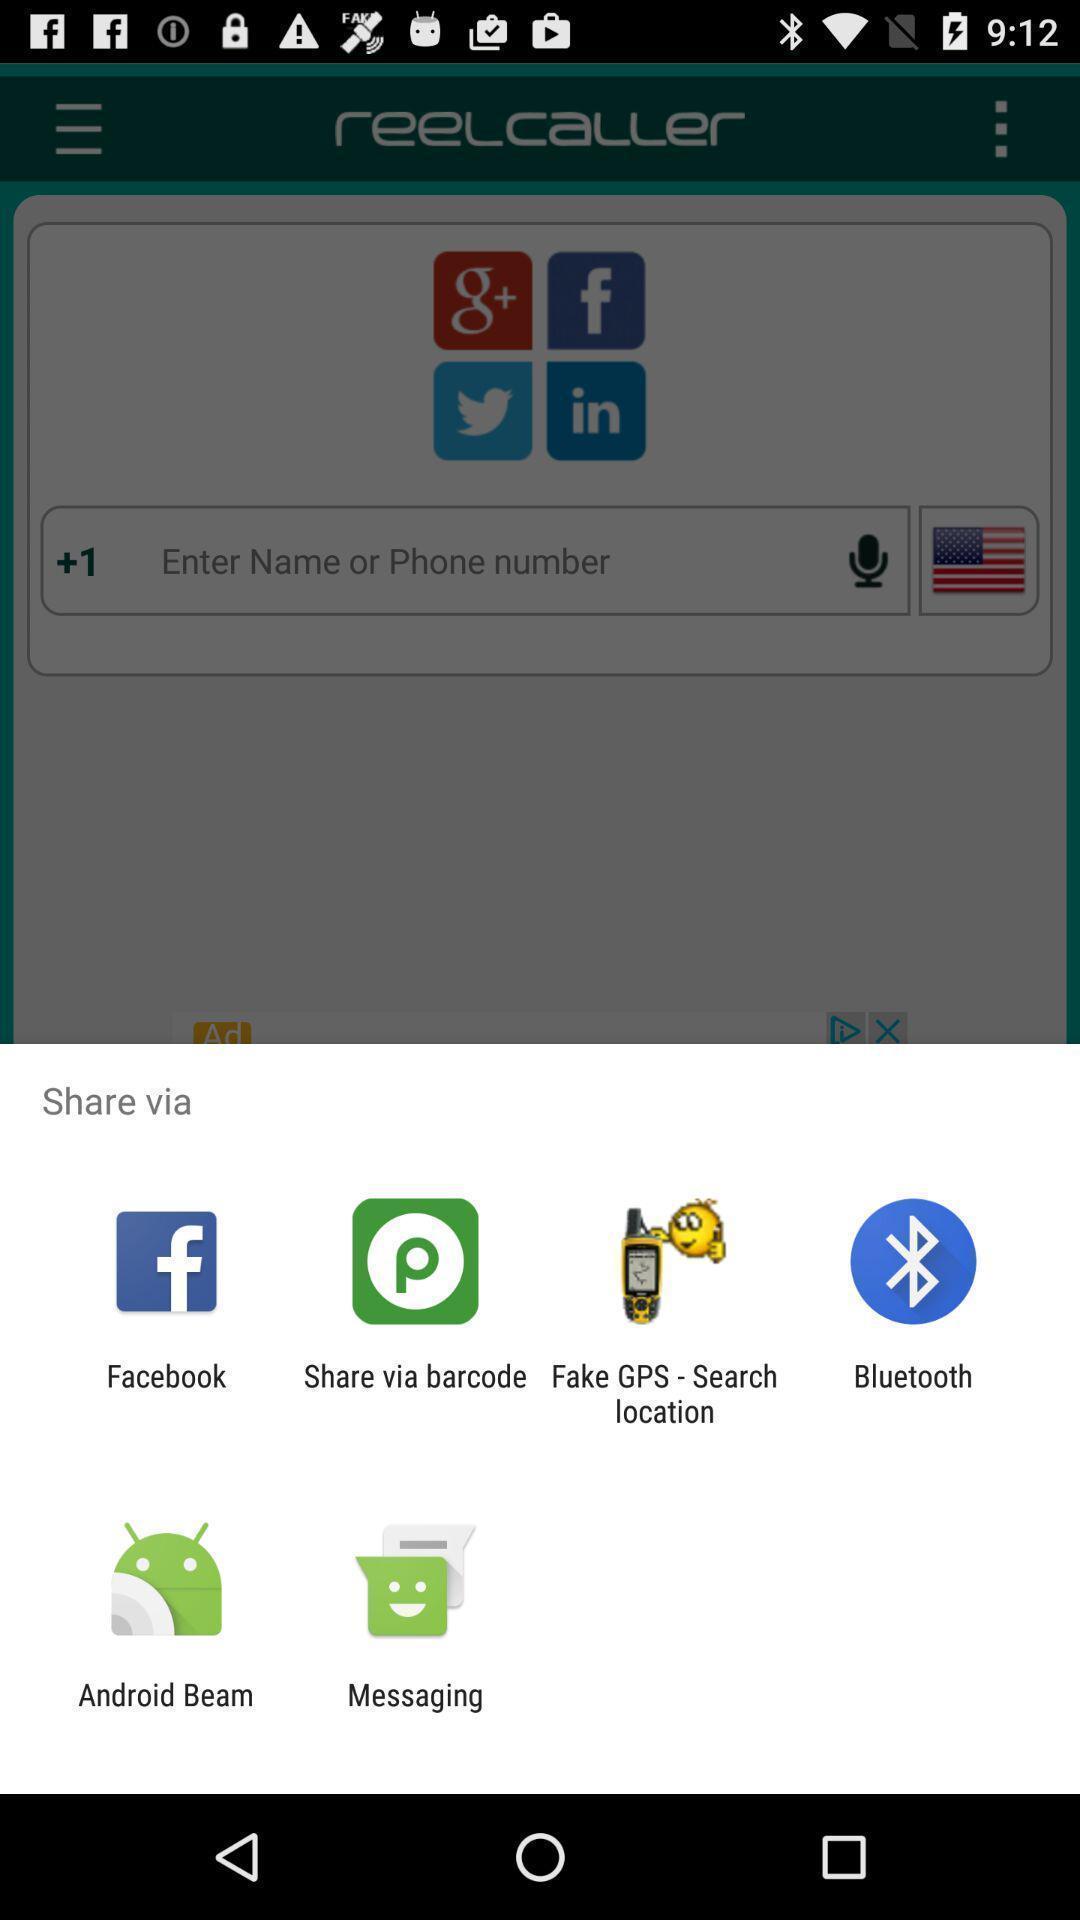Please provide a description for this image. Pop-up shows to share via multiple applications. 